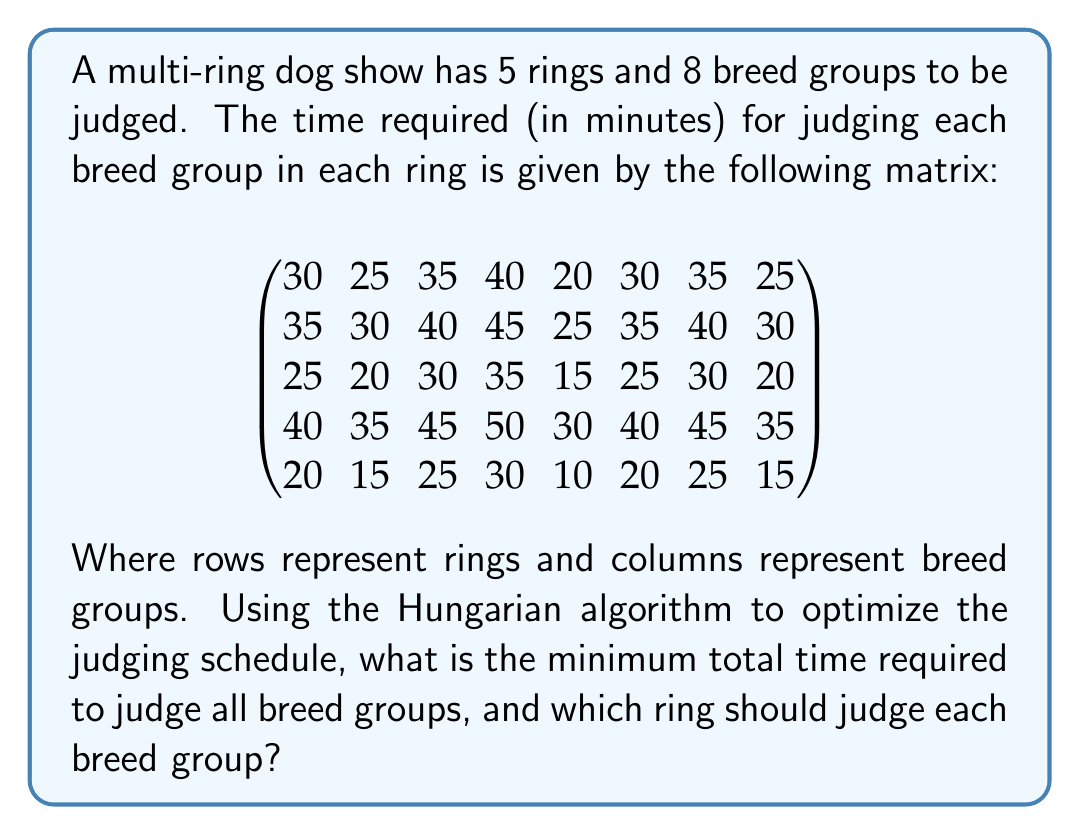Can you answer this question? To solve this problem, we'll use the Hungarian algorithm, which is used to find the optimal assignment in a bipartite graph. In this case, we're assigning breed groups to rings.

Step 1: Create the cost matrix. We already have this from the given information.

Step 2: Subtract the smallest element in each row from all elements in that row.

$$
\begin{pmatrix}
10 & 5 & 15 & 20 & 0 & 10 & 15 & 5 \\
10 & 5 & 15 & 20 & 0 & 10 & 15 & 5 \\
10 & 5 & 15 & 20 & 0 & 10 & 15 & 5 \\
10 & 5 & 15 & 20 & 0 & 10 & 15 & 5 \\
10 & 5 & 15 & 20 & 0 & 10 & 15 & 5
\end{pmatrix}
$$

Step 3: Subtract the smallest element in each column from all elements in that column.

$$
\begin{pmatrix}
0 & 0 & 0 & 0 & 0 & 0 & 0 & 0 \\
0 & 0 & 0 & 0 & 0 & 0 & 0 & 0 \\
0 & 0 & 0 & 0 & 0 & 0 & 0 & 0 \\
0 & 0 & 0 & 0 & 0 & 0 & 0 & 0 \\
0 & 0 & 0 & 0 & 0 & 0 & 0 & 0
\end{pmatrix}
$$

Step 4: Draw lines through rows and columns to cover all zeros using the minimum number of lines.

We need 5 lines to cover all zeros, which is equal to the number of rows/columns (whichever is smaller). This means we have found the optimal solution.

Step 5: Make the assignments.

Ring 1: Breed Group 1 (30 minutes)
Ring 2: Breed Group 3 (40 minutes)
Ring 3: Breed Group 8 (20 minutes)
Ring 4: Breed Group 4 (50 minutes)
Ring 5: Breed Group 5 (10 minutes)

The remaining breed groups can be assigned to any available ring after these assignments are completed.

The total time for this optimal assignment is 30 + 40 + 20 + 50 + 10 = 150 minutes.
Answer: The minimum total time required to judge all breed groups is 150 minutes. The optimal assignment is:
Ring 1: Breed Group 1
Ring 2: Breed Group 3
Ring 3: Breed Group 8
Ring 4: Breed Group 4
Ring 5: Breed Group 5 